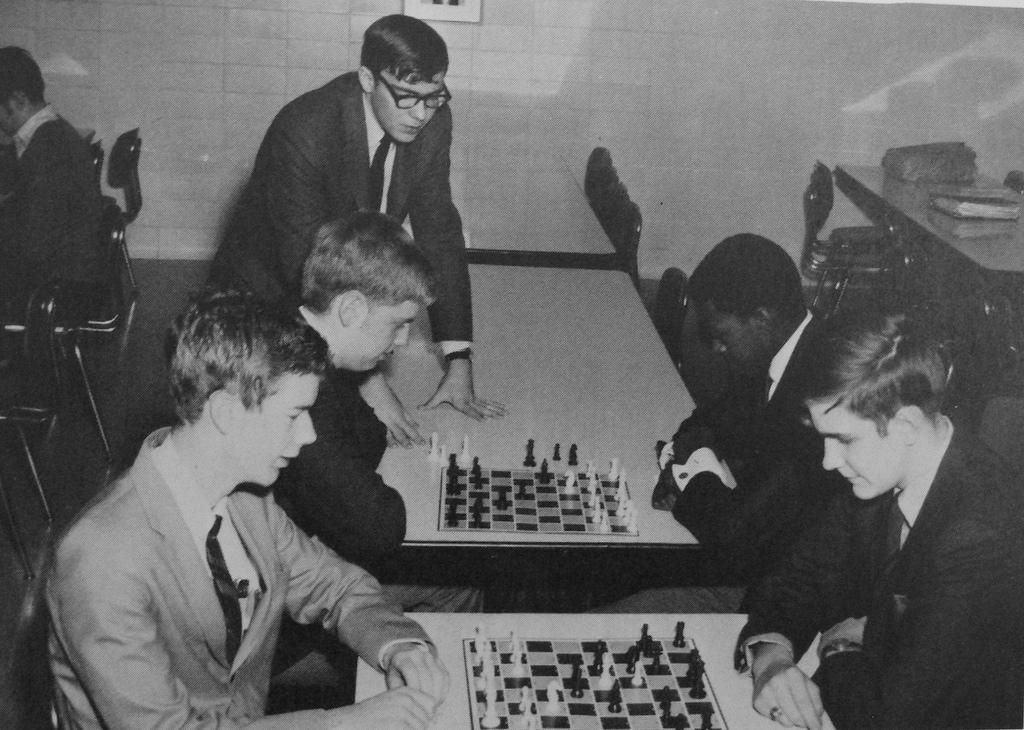Please provide a concise description of this image. In this picture were a group of people sitting in the chair , another group of people sitting in the chair and they are playing the chess game in the table and in back ground we have a wall and some persons sitting in the chairs. 